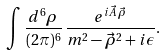<formula> <loc_0><loc_0><loc_500><loc_500>\int \frac { d ^ { 6 } \rho } { ( 2 \pi ) ^ { 6 } } \, \frac { e ^ { i \vec { A } \, \vec { \rho } } } { m ^ { 2 } - \vec { \rho } ^ { 2 } + i \epsilon } .</formula> 